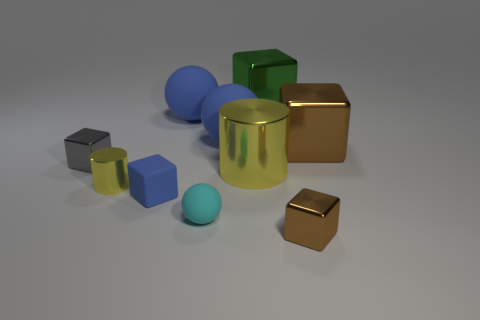Subtract all gray blocks. How many blocks are left? 4 Subtract all large green blocks. How many blocks are left? 4 Subtract all green blocks. Subtract all brown balls. How many blocks are left? 4 Subtract all cylinders. How many objects are left? 8 Add 1 large yellow cubes. How many large yellow cubes exist? 1 Subtract 0 brown cylinders. How many objects are left? 10 Subtract all matte spheres. Subtract all green things. How many objects are left? 6 Add 2 big yellow things. How many big yellow things are left? 3 